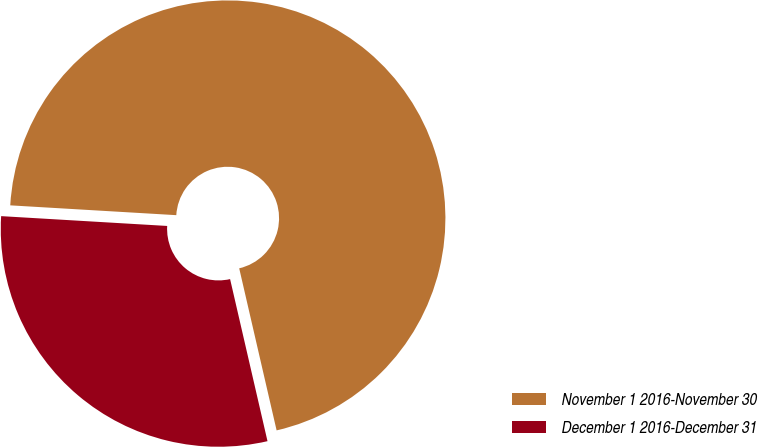Convert chart. <chart><loc_0><loc_0><loc_500><loc_500><pie_chart><fcel>November 1 2016-November 30<fcel>December 1 2016-December 31<nl><fcel>70.45%<fcel>29.55%<nl></chart> 